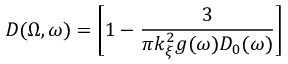Convert formula to latex. <formula><loc_0><loc_0><loc_500><loc_500>D ( \Omega , \omega ) = \left [ 1 - \frac { 3 } { \pi k _ { \xi } ^ { 2 } g ( \omega ) D _ { 0 } ( \omega ) } \right ]</formula> 